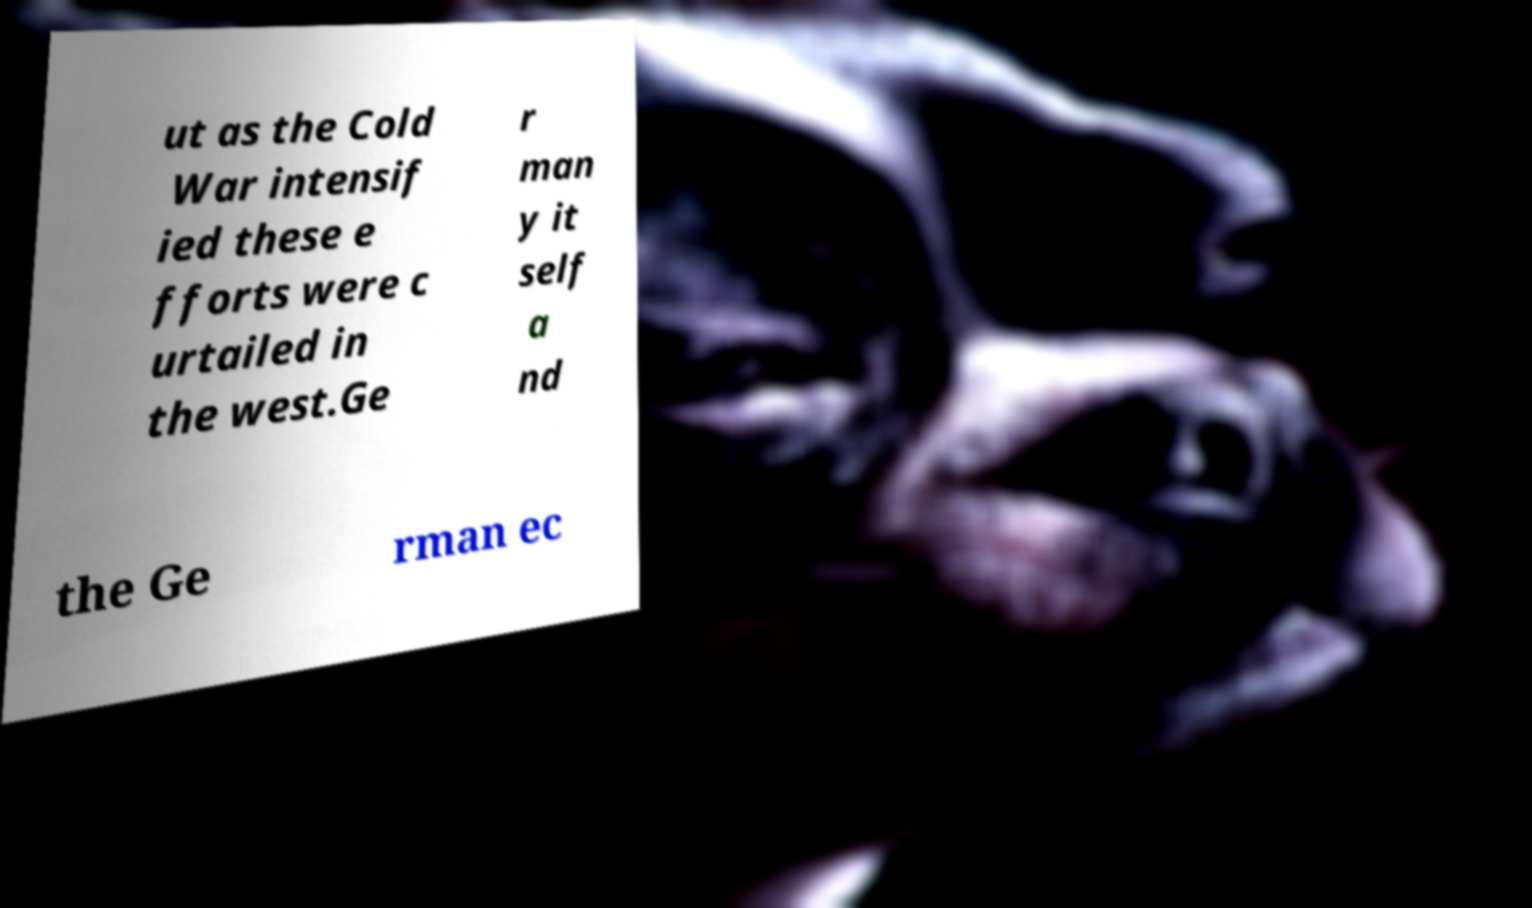Could you assist in decoding the text presented in this image and type it out clearly? ut as the Cold War intensif ied these e fforts were c urtailed in the west.Ge r man y it self a nd the Ge rman ec 